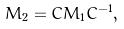<formula> <loc_0><loc_0><loc_500><loc_500>M _ { 2 } = C M _ { 1 } C ^ { - 1 } ,</formula> 